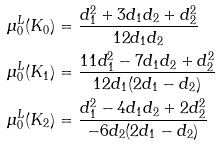<formula> <loc_0><loc_0><loc_500><loc_500>\mu _ { 0 } ^ { L } ( K _ { 0 } ) & = \frac { d _ { 1 } ^ { 2 } + 3 d _ { 1 } d _ { 2 } + d _ { 2 } ^ { 2 } } { 1 2 d _ { 1 } d _ { 2 } } \\ \mu _ { 0 } ^ { L } ( K _ { 1 } ) & = \frac { 1 1 d _ { 1 } ^ { 2 } - 7 d _ { 1 } d _ { 2 } + d _ { 2 } ^ { 2 } } { 1 2 d _ { 1 } ( 2 d _ { 1 } - d _ { 2 } ) } \\ \mu _ { 0 } ^ { L } ( K _ { 2 } ) & = \frac { d _ { 1 } ^ { 2 } - 4 d _ { 1 } d _ { 2 } + 2 d _ { 2 } ^ { 2 } } { - 6 d _ { 2 } ( 2 d _ { 1 } - d _ { 2 } ) }</formula> 